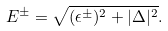Convert formula to latex. <formula><loc_0><loc_0><loc_500><loc_500>E ^ { \pm } = \sqrt { ( \epsilon ^ { \pm } ) ^ { 2 } + | \Delta | ^ { 2 } } .</formula> 